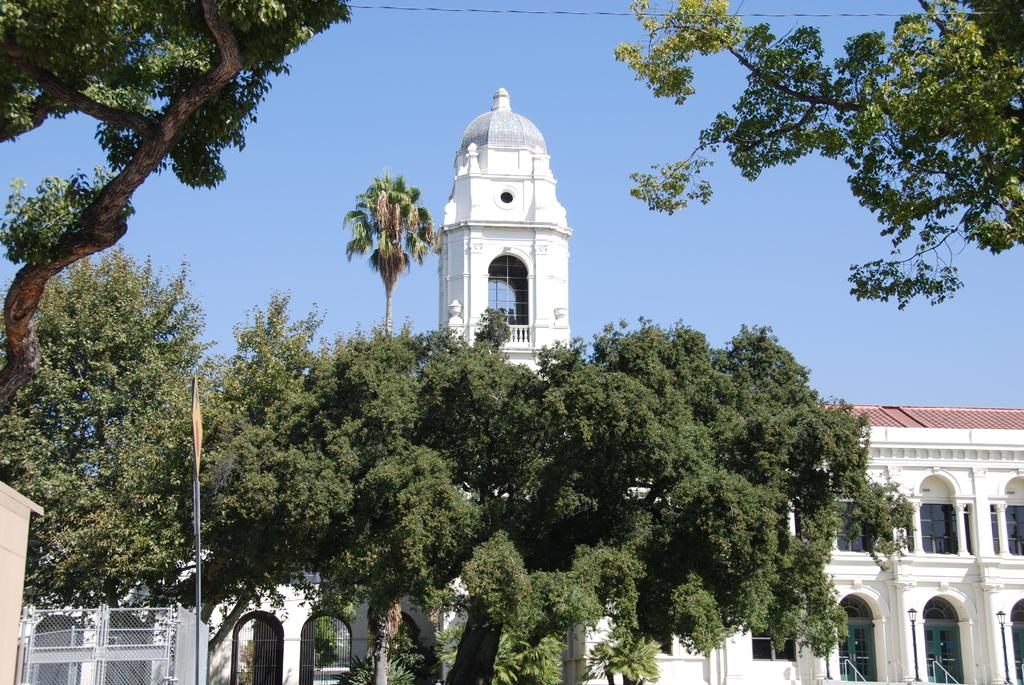What can be seen in the foreground of the picture? There are trees, a sign board, and a railing in the foreground of the picture. What is located in the center of the picture? There is a building in the center of the picture. What is the condition of the sky in the picture? The sky is cloudy in the picture. Where is the faucet located in the picture? There is no faucet present in the picture. What type of fuel is being used by the building in the picture? There is no information about the building's fuel source in the picture. 